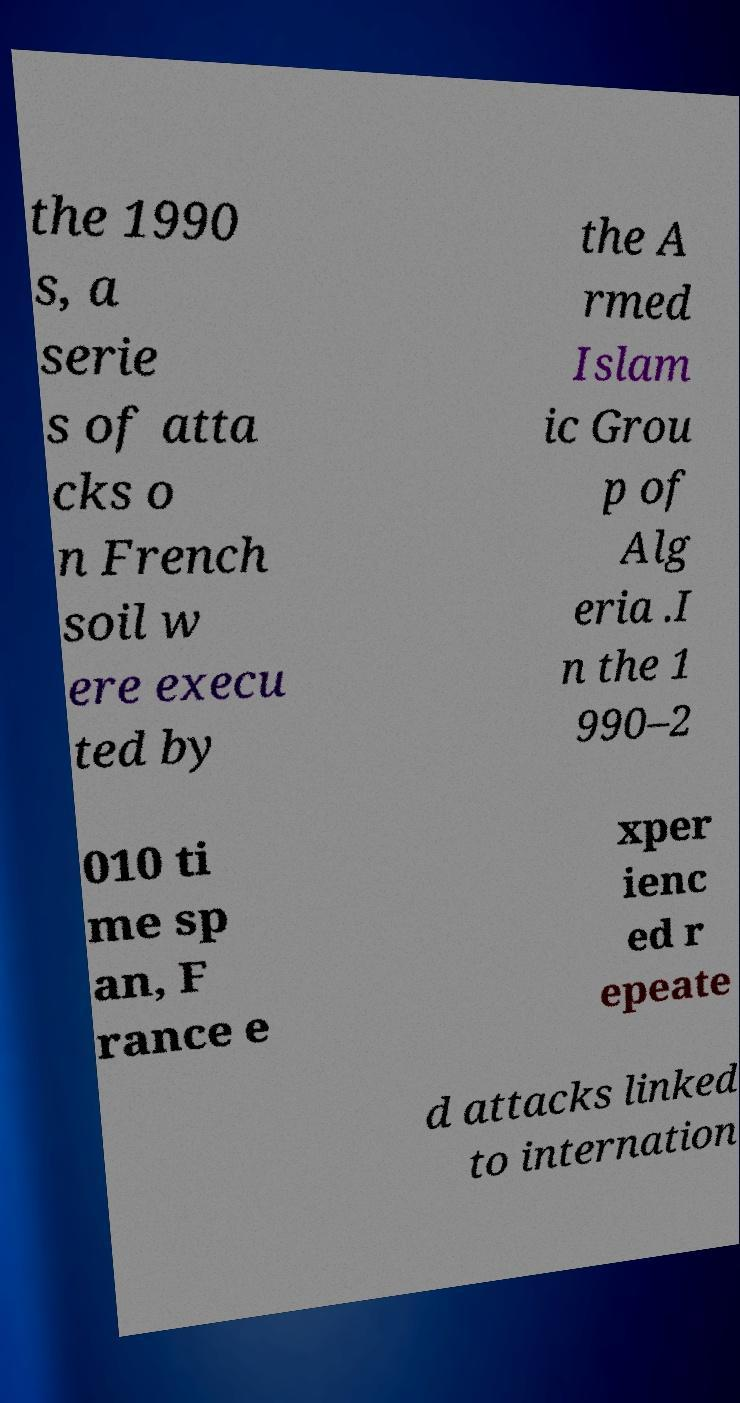What messages or text are displayed in this image? I need them in a readable, typed format. the 1990 s, a serie s of atta cks o n French soil w ere execu ted by the A rmed Islam ic Grou p of Alg eria .I n the 1 990–2 010 ti me sp an, F rance e xper ienc ed r epeate d attacks linked to internation 